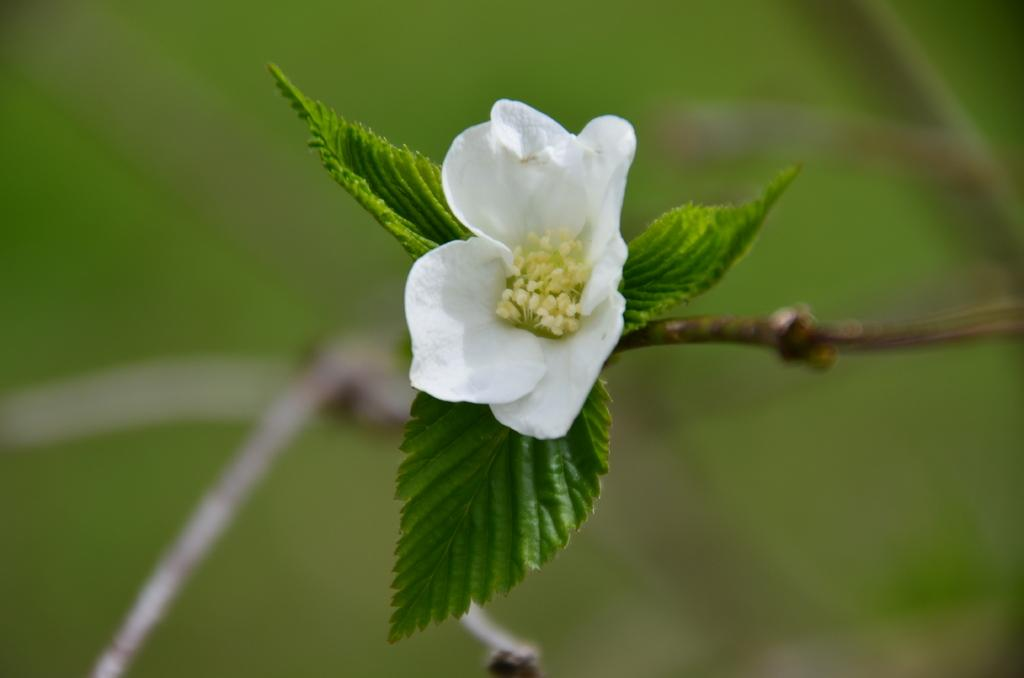What type of plant can be seen in the image? The image contains a flower. What other parts of the plant are visible in the image? The image contains leaves. What color is the background of the flower? The background of the flower is blue. What type of wealth is represented by the flower in the image? The image does not represent any type of wealth; it simply contains a flower and leaves. How does the behavior of the flower change throughout the day in the image? The image does not depict any changes in the behavior of the flower; it is a static image. 